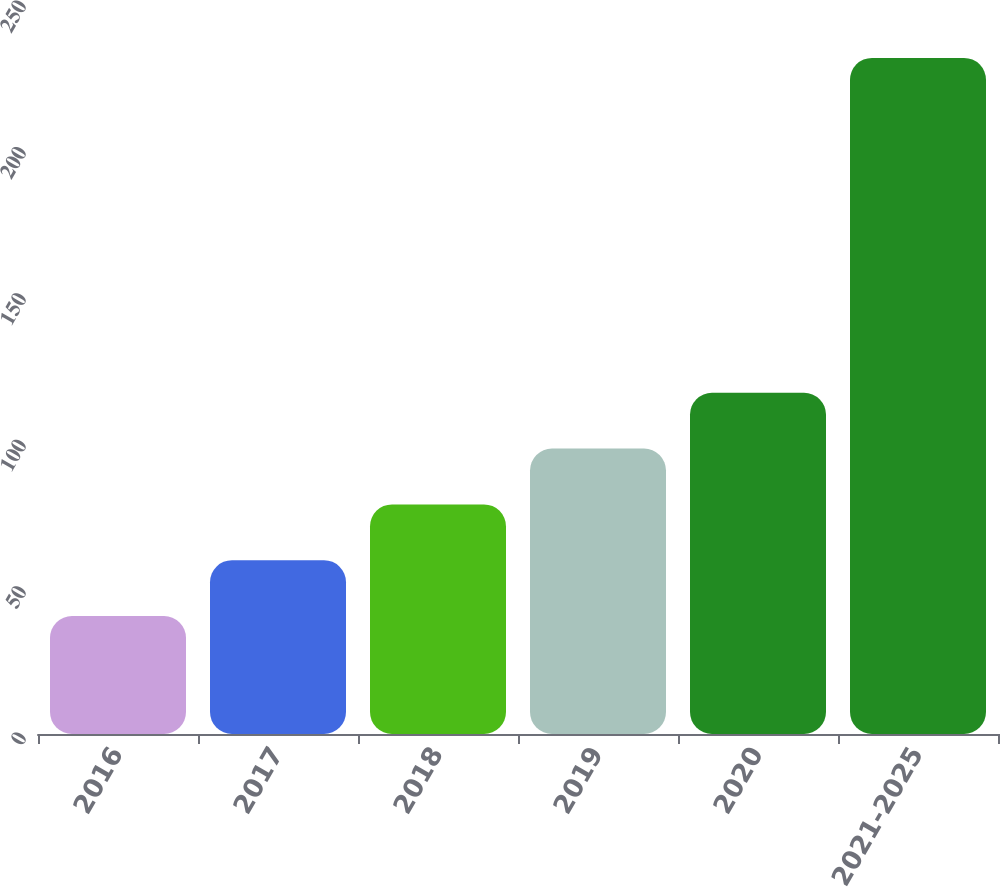<chart> <loc_0><loc_0><loc_500><loc_500><bar_chart><fcel>2016<fcel>2017<fcel>2018<fcel>2019<fcel>2020<fcel>2021-2025<nl><fcel>40.3<fcel>59.36<fcel>78.42<fcel>97.48<fcel>116.54<fcel>230.9<nl></chart> 